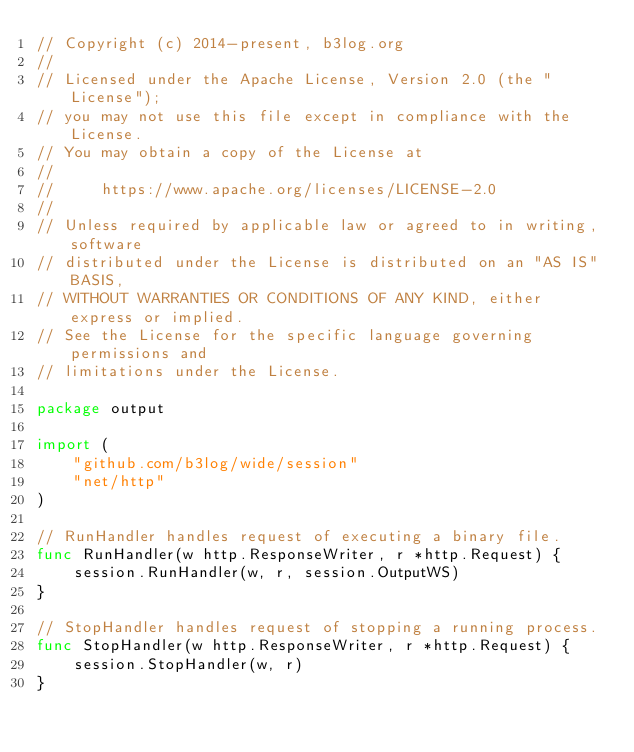<code> <loc_0><loc_0><loc_500><loc_500><_Go_>// Copyright (c) 2014-present, b3log.org
//
// Licensed under the Apache License, Version 2.0 (the "License");
// you may not use this file except in compliance with the License.
// You may obtain a copy of the License at
//
//     https://www.apache.org/licenses/LICENSE-2.0
//
// Unless required by applicable law or agreed to in writing, software
// distributed under the License is distributed on an "AS IS" BASIS,
// WITHOUT WARRANTIES OR CONDITIONS OF ANY KIND, either express or implied.
// See the License for the specific language governing permissions and
// limitations under the License.

package output

import (
	"github.com/b3log/wide/session"
	"net/http"
)

// RunHandler handles request of executing a binary file.
func RunHandler(w http.ResponseWriter, r *http.Request) {
	session.RunHandler(w, r, session.OutputWS)
}

// StopHandler handles request of stopping a running process.
func StopHandler(w http.ResponseWriter, r *http.Request) {
	session.StopHandler(w, r)
}
</code> 